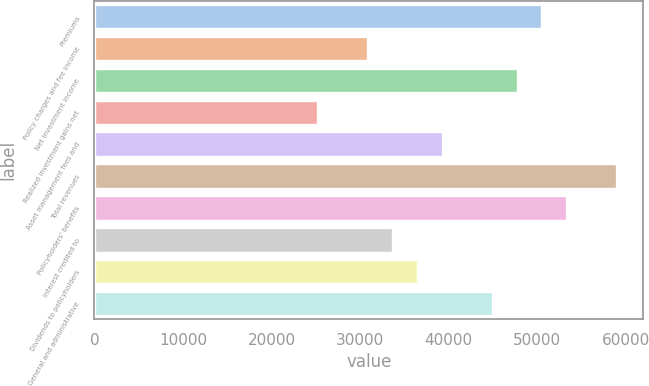Convert chart. <chart><loc_0><loc_0><loc_500><loc_500><bar_chart><fcel>Premiums<fcel>Policy charges and fee income<fcel>Net investment income<fcel>Realized investment gains net<fcel>Asset management fees and<fcel>Total revenues<fcel>Policyholders' benefits<fcel>Interest credited to<fcel>Dividends to policyholders<fcel>General and administrative<nl><fcel>50572.6<fcel>30905.5<fcel>47763<fcel>25286.4<fcel>39334.3<fcel>59001.3<fcel>53382.2<fcel>33715.1<fcel>36524.7<fcel>44953.4<nl></chart> 